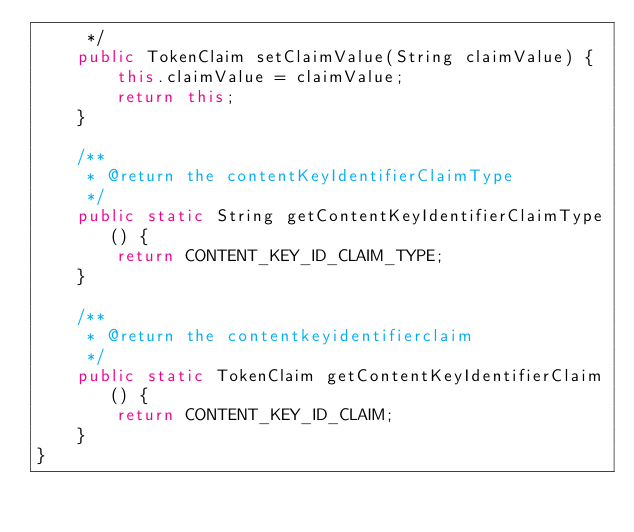Convert code to text. <code><loc_0><loc_0><loc_500><loc_500><_Java_>     */
    public TokenClaim setClaimValue(String claimValue) {
        this.claimValue = claimValue;
        return this;
    }

    /**
     * @return the contentKeyIdentifierClaimType
     */
    public static String getContentKeyIdentifierClaimType() {
        return CONTENT_KEY_ID_CLAIM_TYPE;
    }

    /**
     * @return the contentkeyidentifierclaim
     */
    public static TokenClaim getContentKeyIdentifierClaim() {
        return CONTENT_KEY_ID_CLAIM;
    }
}
</code> 